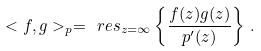<formula> <loc_0><loc_0><loc_500><loc_500>< f , g > _ { p } = \ r e s _ { z = \infty } \left \{ \frac { f ( z ) g ( z ) } { p ^ { \prime } ( z ) } \right \} \, .</formula> 